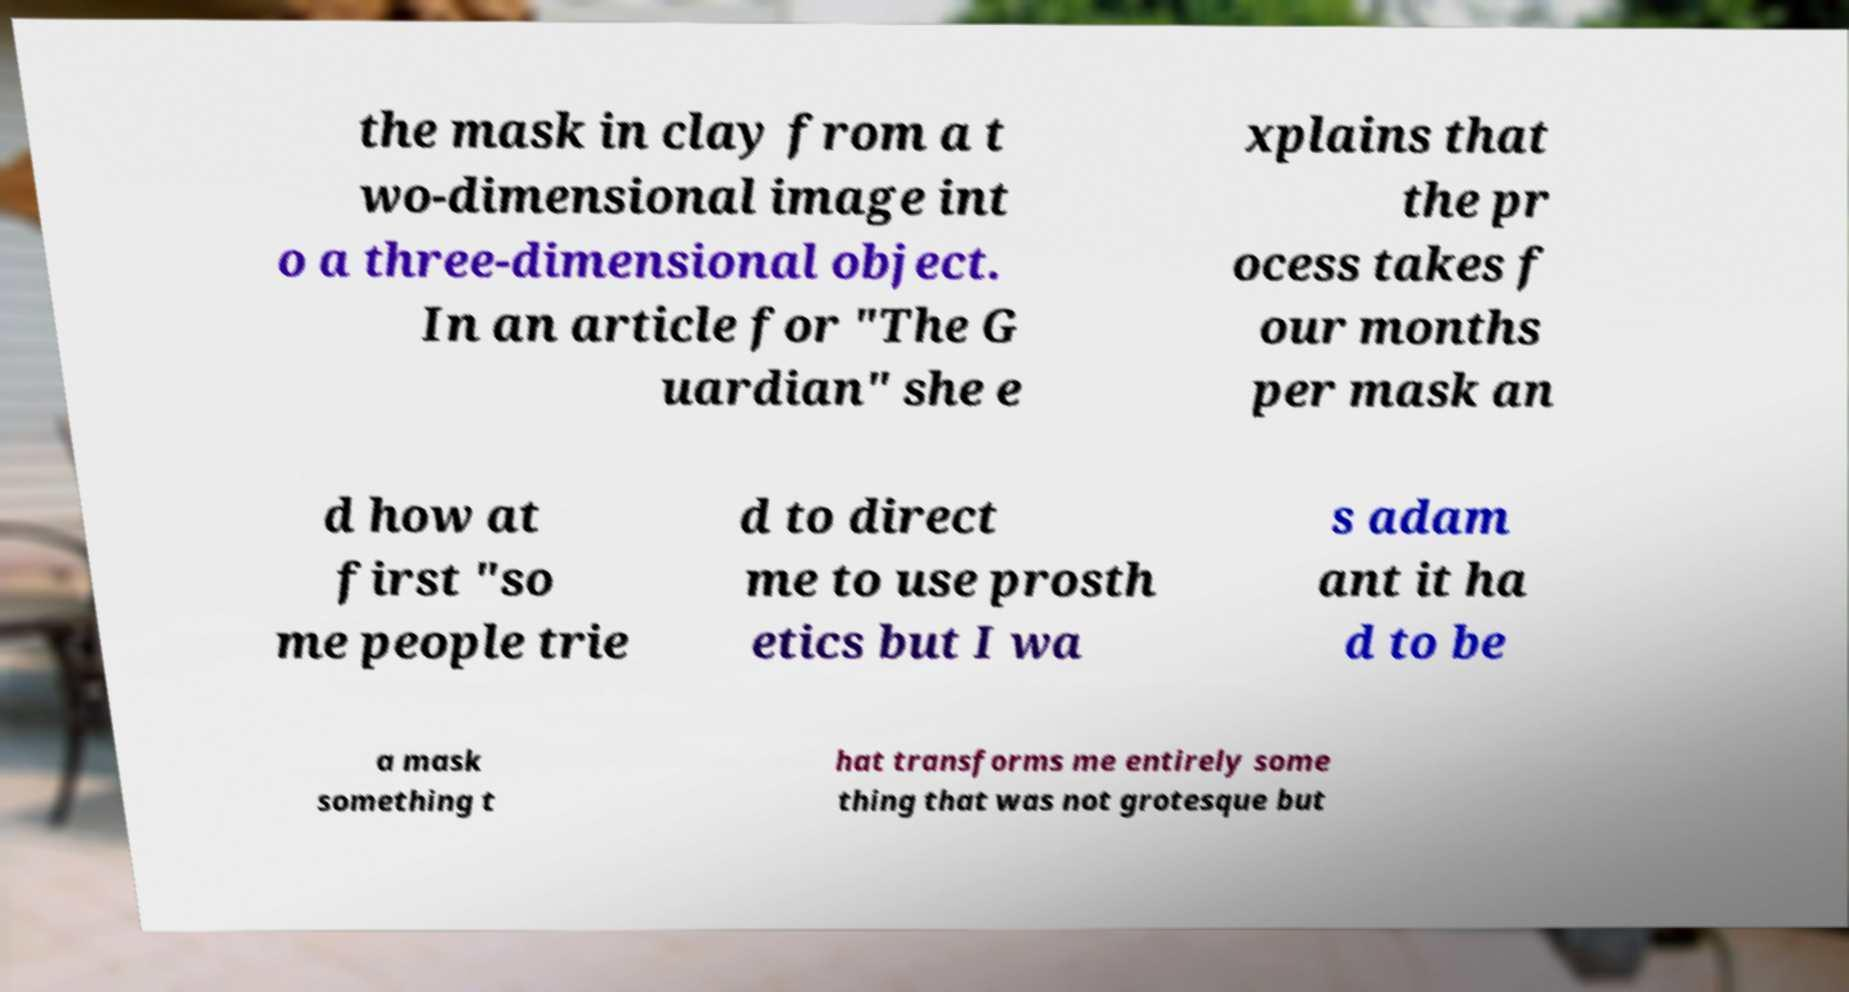Could you assist in decoding the text presented in this image and type it out clearly? the mask in clay from a t wo-dimensional image int o a three-dimensional object. In an article for "The G uardian" she e xplains that the pr ocess takes f our months per mask an d how at first "so me people trie d to direct me to use prosth etics but I wa s adam ant it ha d to be a mask something t hat transforms me entirely some thing that was not grotesque but 